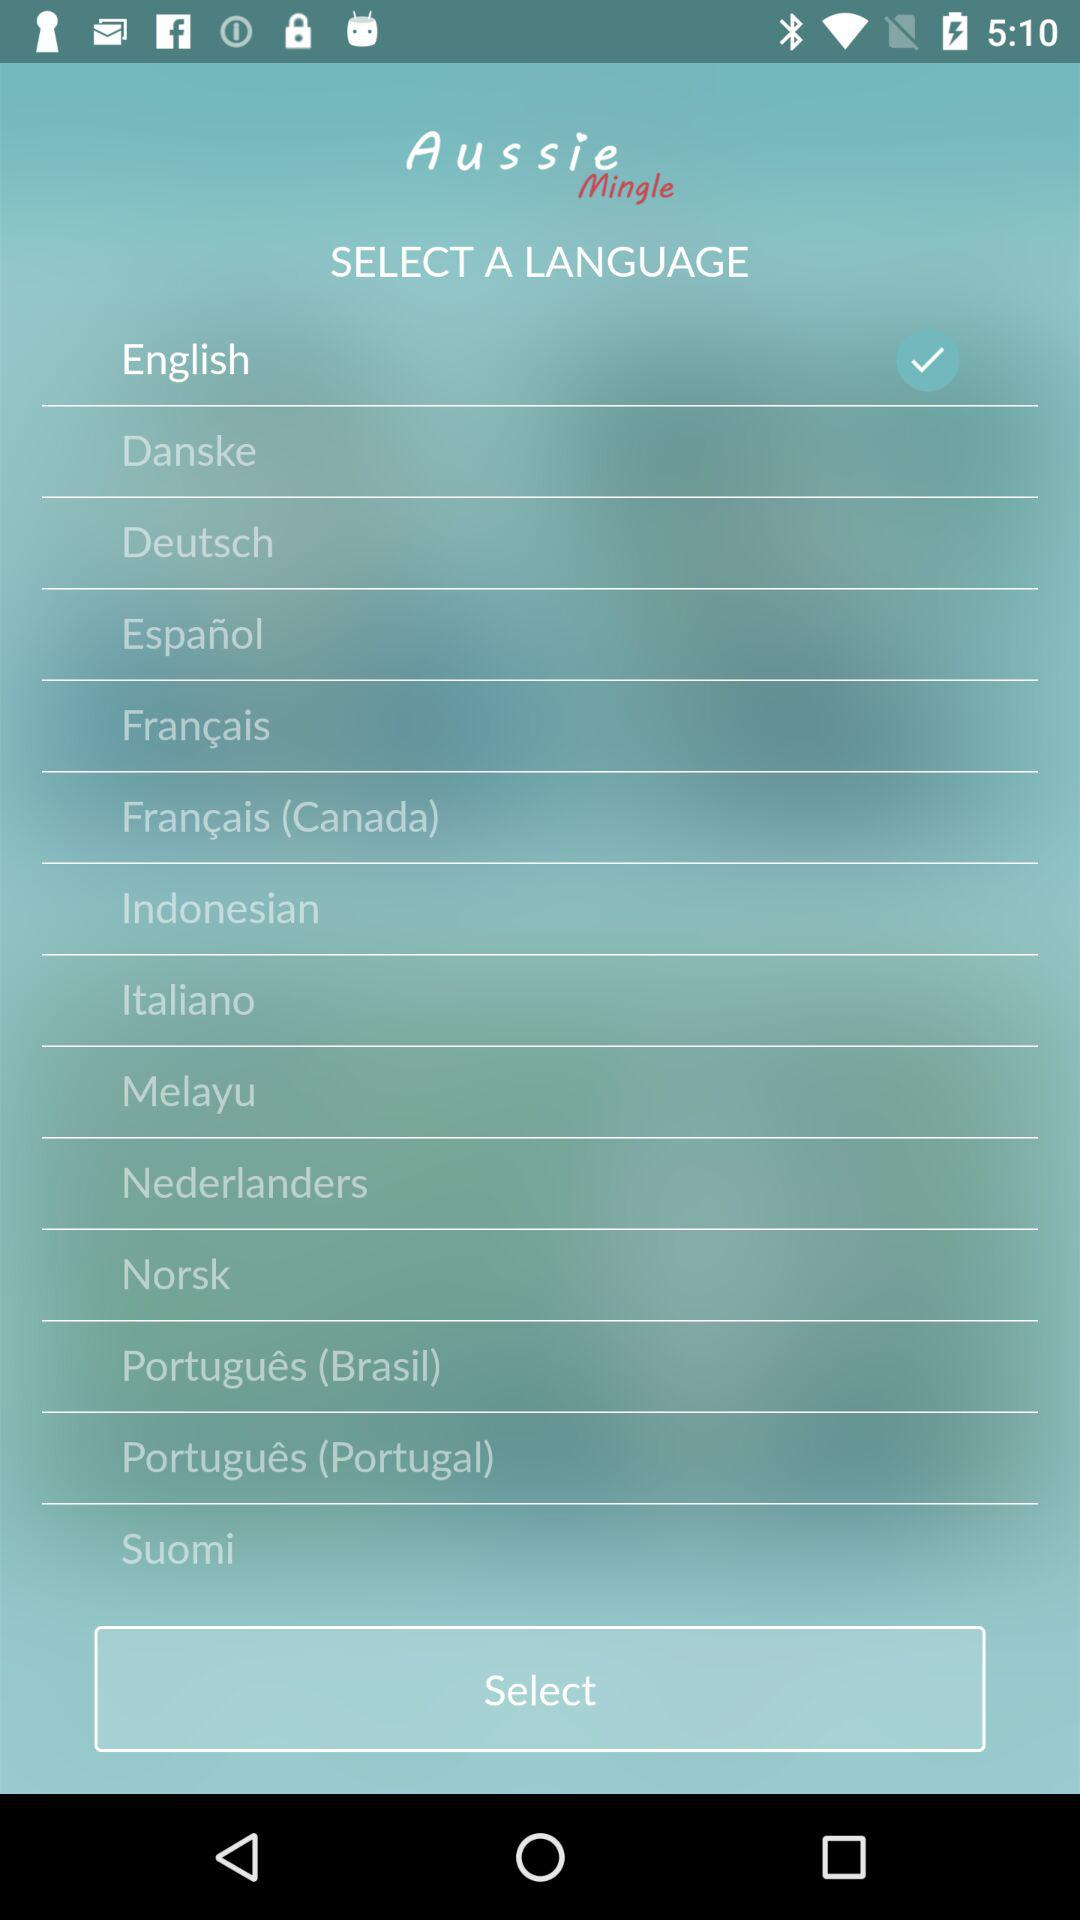What is the name of the application? The name of the application is "Aussie Mingle". 